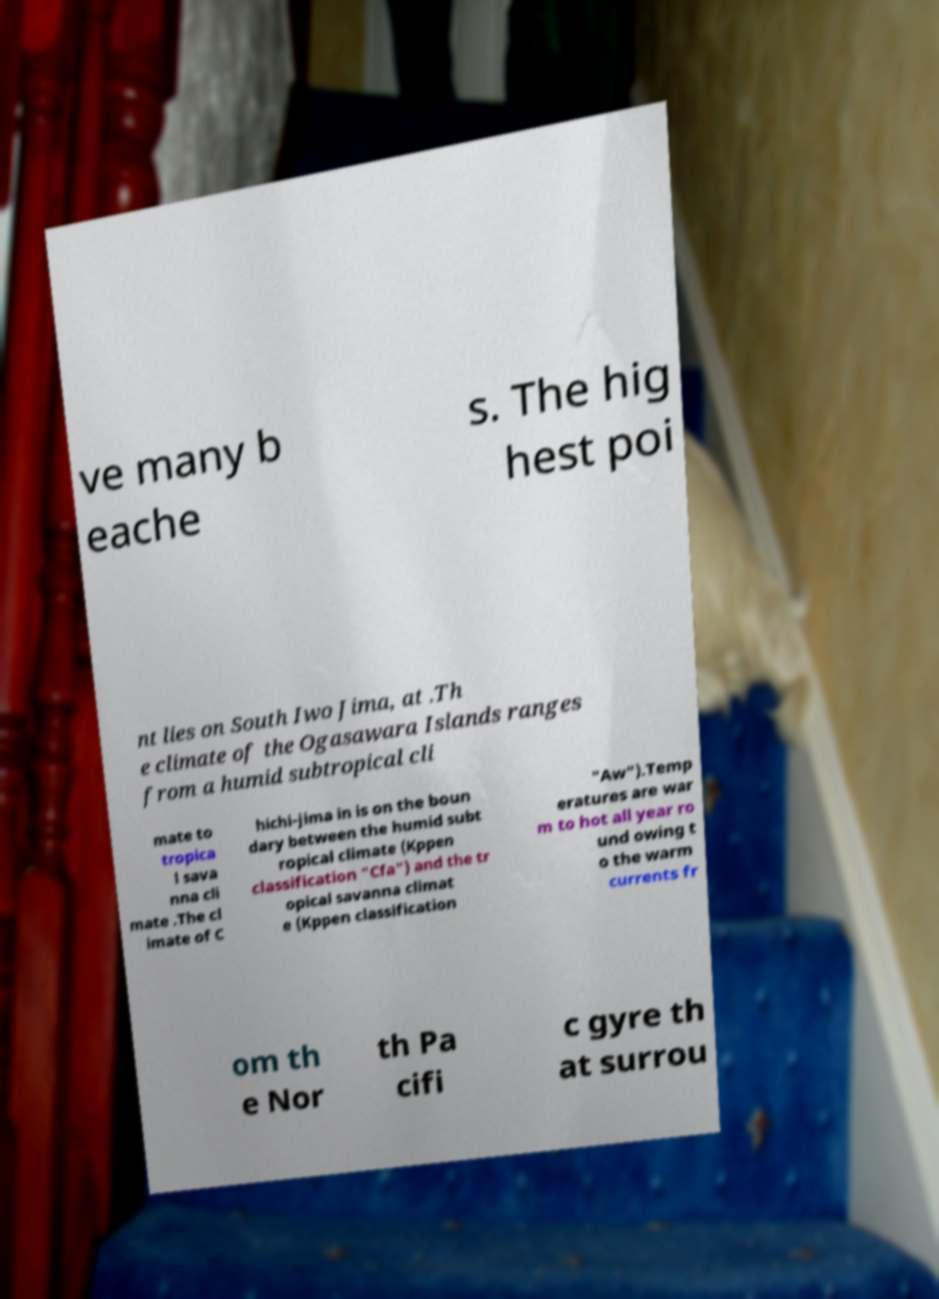Could you extract and type out the text from this image? ve many b eache s. The hig hest poi nt lies on South Iwo Jima, at .Th e climate of the Ogasawara Islands ranges from a humid subtropical cli mate to tropica l sava nna cli mate .The cl imate of C hichi-jima in is on the boun dary between the humid subt ropical climate (Kppen classification "Cfa") and the tr opical savanna climat e (Kppen classification "Aw").Temp eratures are war m to hot all year ro und owing t o the warm currents fr om th e Nor th Pa cifi c gyre th at surrou 